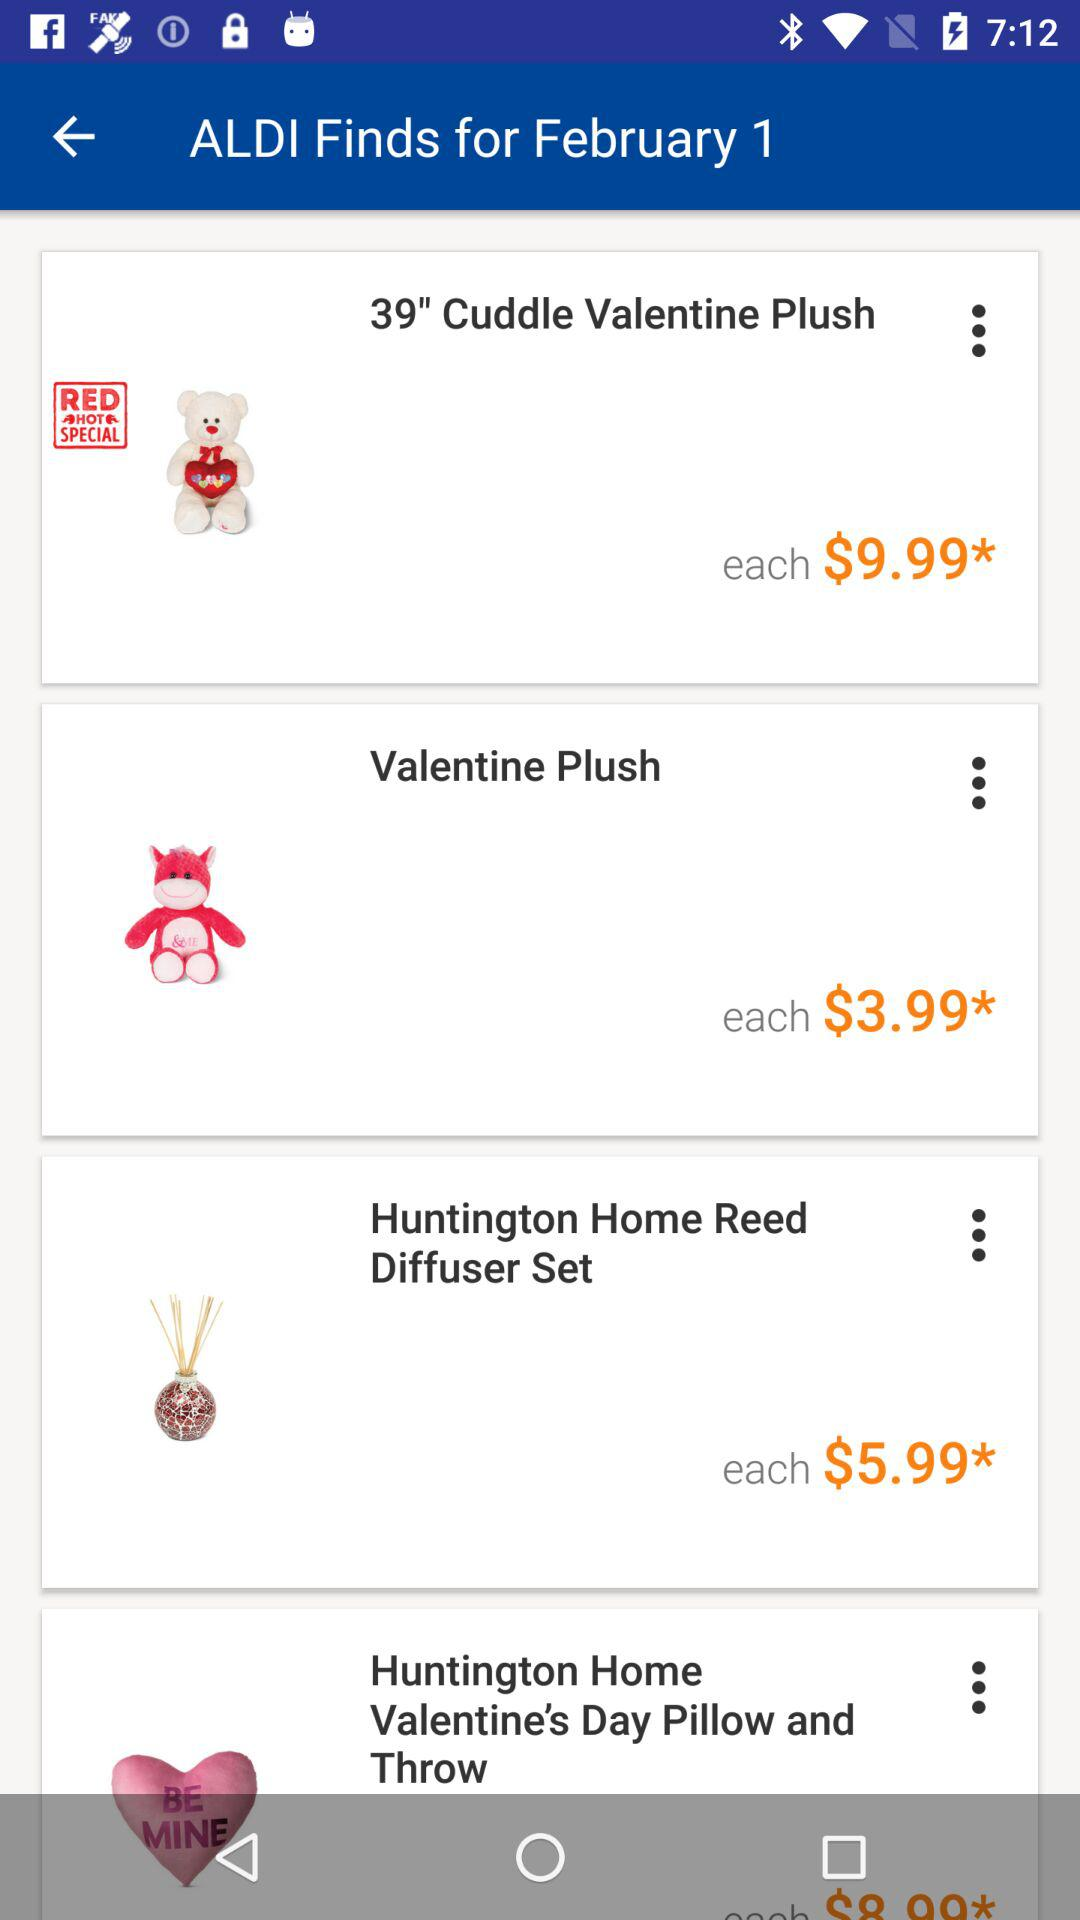What is the price of the "Huntington Home Reed Diffuser Set"? The price of the "Huntington Home Reed Diffuser Set" is $5.99. 